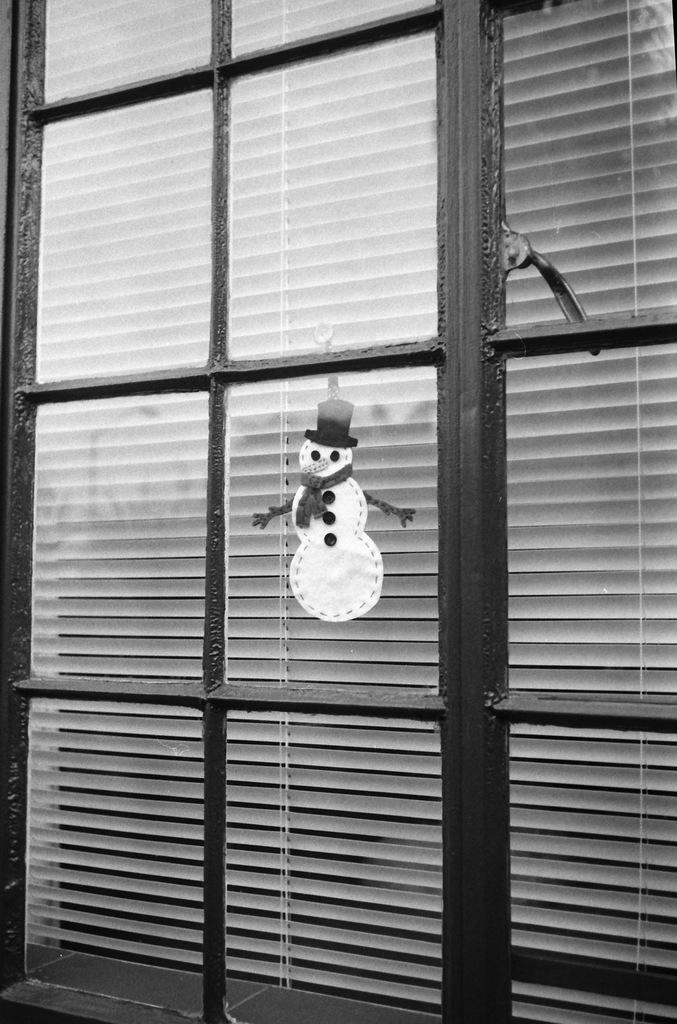What type of object is made of glass in the image? There is a glass object in the image, but its specific form is not mentioned. What seasonal figure can be seen in the image? There is a snowman in the image. What accessories is the snowman wearing? The snowman is wearing a hat and a scarf. What type of window treatment is visible in the image? There are window blinds in the image. Can you hear the grandmother crying in the image? There is no mention of a grandmother or any crying in the image. The image features a snowman, a glass object, and window blinds. 